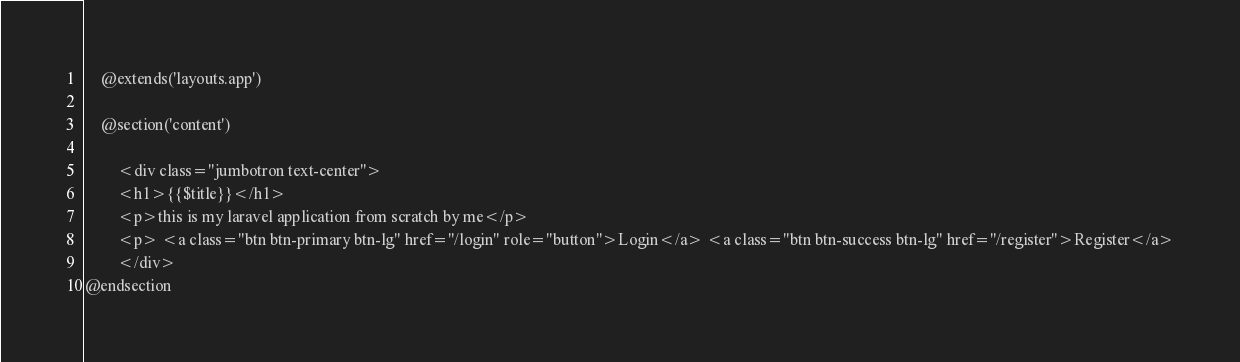<code> <loc_0><loc_0><loc_500><loc_500><_PHP_>    @extends('layouts.app')

    @section('content')

        <div class="jumbotron text-center">
        <h1>{{$title}}</h1>
        <p>this is my laravel application from scratch by me</p>
        <p> <a class="btn btn-primary btn-lg" href="/login" role="button">Login</a> <a class="btn btn-success btn-lg" href="/register">Register</a>
        </div>
@endsection
</code> 